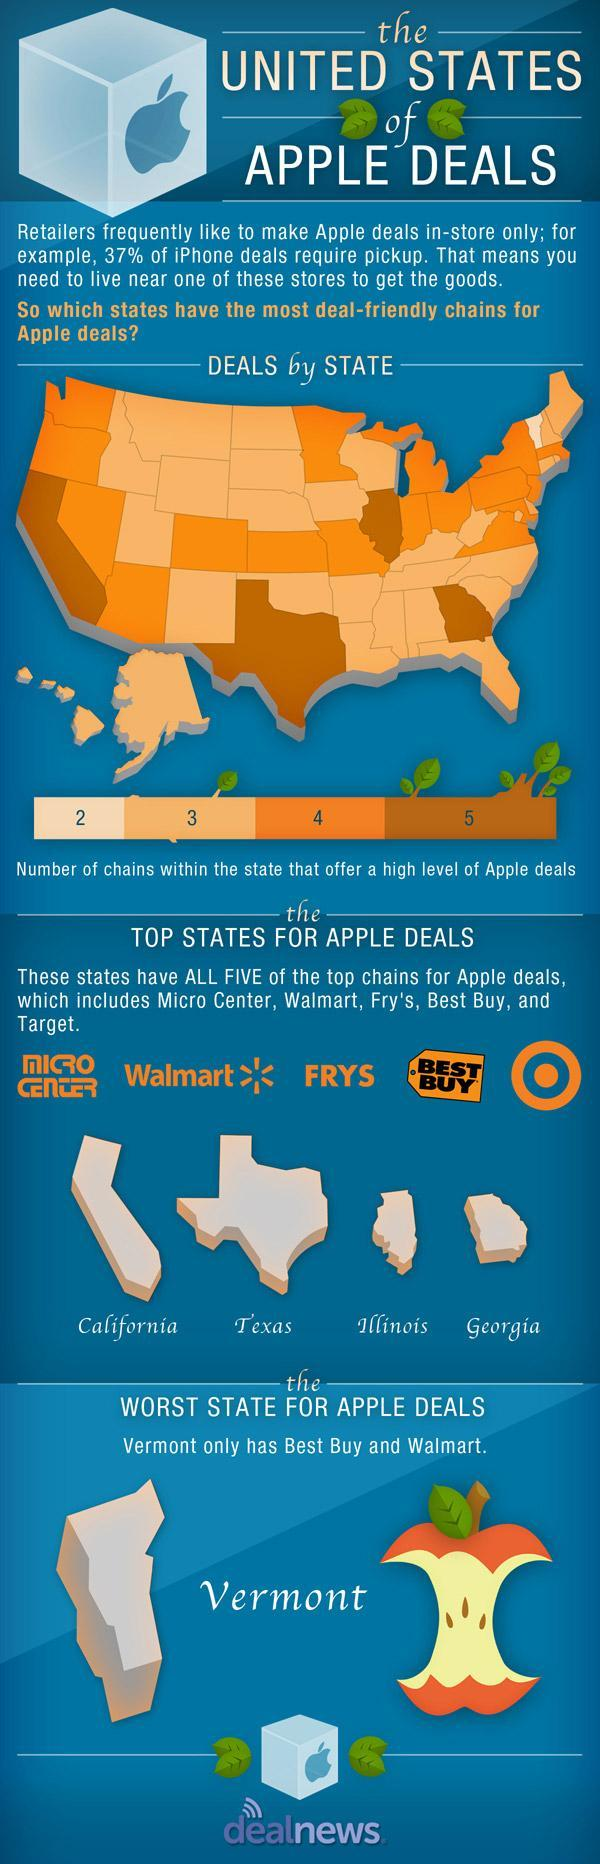Which is the third top state with best Apple deals?
Answer the question with a short phrase. Illinois How many states have chains that offer level 5 of Apple deals? 4 